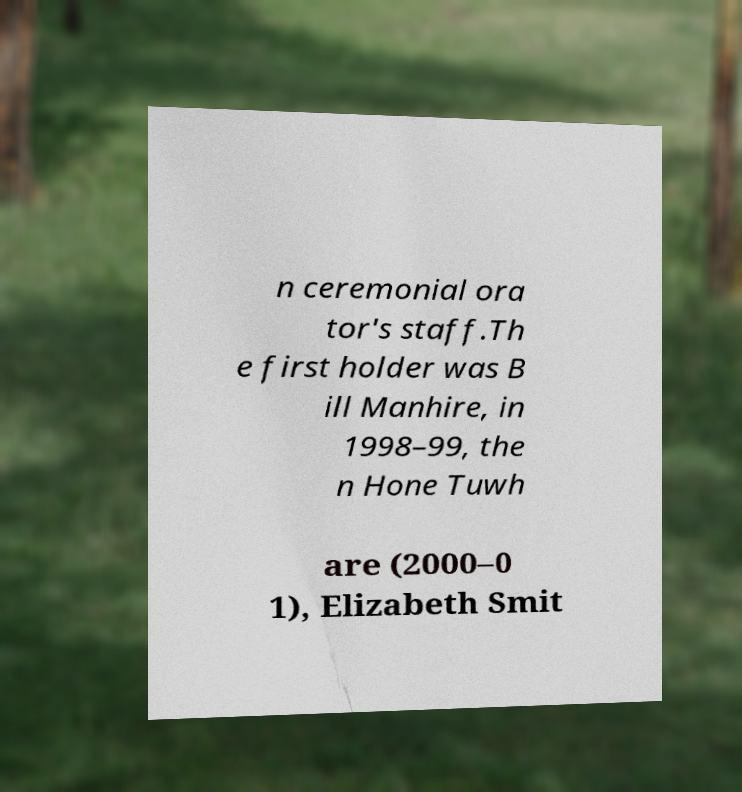There's text embedded in this image that I need extracted. Can you transcribe it verbatim? n ceremonial ora tor's staff.Th e first holder was B ill Manhire, in 1998–99, the n Hone Tuwh are (2000–0 1), Elizabeth Smit 